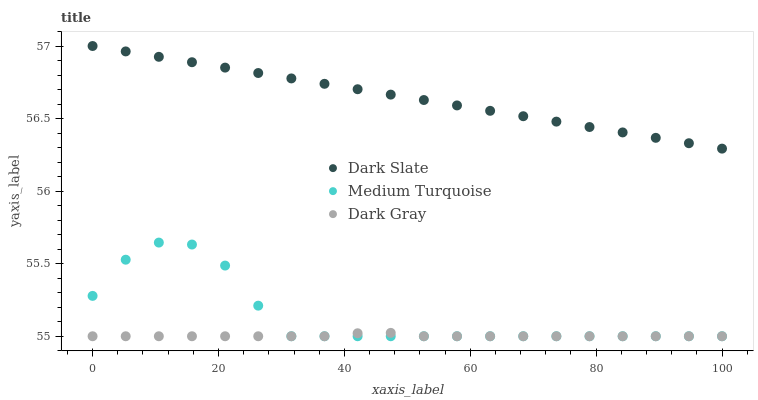Does Dark Gray have the minimum area under the curve?
Answer yes or no. Yes. Does Dark Slate have the maximum area under the curve?
Answer yes or no. Yes. Does Medium Turquoise have the minimum area under the curve?
Answer yes or no. No. Does Medium Turquoise have the maximum area under the curve?
Answer yes or no. No. Is Dark Slate the smoothest?
Answer yes or no. Yes. Is Medium Turquoise the roughest?
Answer yes or no. Yes. Is Medium Turquoise the smoothest?
Answer yes or no. No. Is Dark Slate the roughest?
Answer yes or no. No. Does Dark Gray have the lowest value?
Answer yes or no. Yes. Does Dark Slate have the lowest value?
Answer yes or no. No. Does Dark Slate have the highest value?
Answer yes or no. Yes. Does Medium Turquoise have the highest value?
Answer yes or no. No. Is Medium Turquoise less than Dark Slate?
Answer yes or no. Yes. Is Dark Slate greater than Medium Turquoise?
Answer yes or no. Yes. Does Dark Gray intersect Medium Turquoise?
Answer yes or no. Yes. Is Dark Gray less than Medium Turquoise?
Answer yes or no. No. Is Dark Gray greater than Medium Turquoise?
Answer yes or no. No. Does Medium Turquoise intersect Dark Slate?
Answer yes or no. No. 